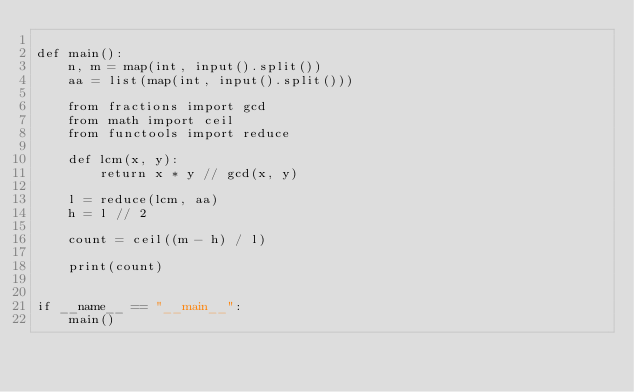<code> <loc_0><loc_0><loc_500><loc_500><_Python_>
def main():
    n, m = map(int, input().split())
    aa = list(map(int, input().split()))

    from fractions import gcd
    from math import ceil
    from functools import reduce

    def lcm(x, y):
        return x * y // gcd(x, y)

    l = reduce(lcm, aa)
    h = l // 2

    count = ceil((m - h) / l)

    print(count)


if __name__ == "__main__":
    main()
</code> 